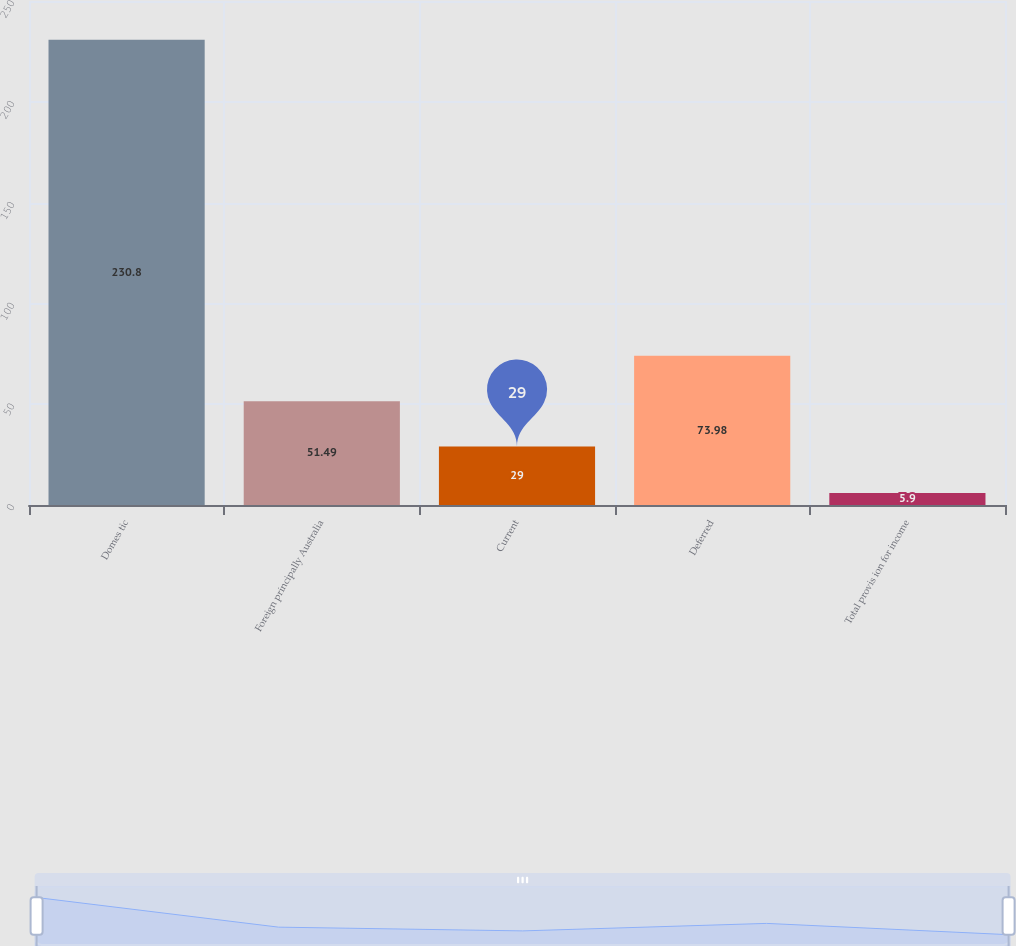<chart> <loc_0><loc_0><loc_500><loc_500><bar_chart><fcel>Domes tic<fcel>Foreign principally Australia<fcel>Current<fcel>Deferred<fcel>Total provis ion for income<nl><fcel>230.8<fcel>51.49<fcel>29<fcel>73.98<fcel>5.9<nl></chart> 